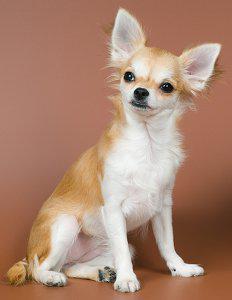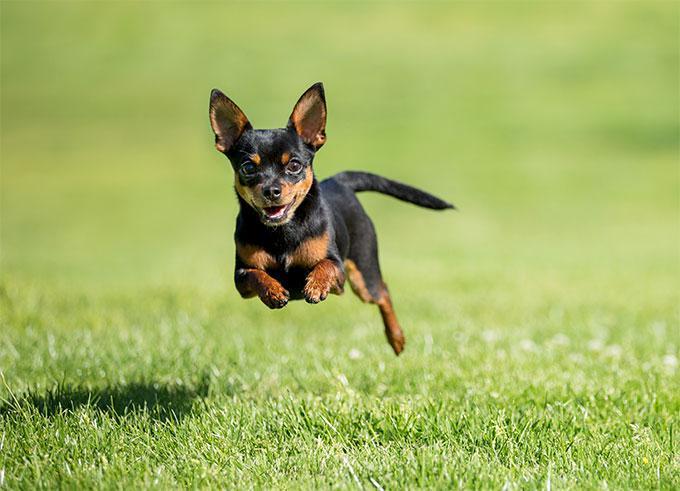The first image is the image on the left, the second image is the image on the right. Given the left and right images, does the statement "At least one image shows a small dog standing on green grass." hold true? Answer yes or no. No. 